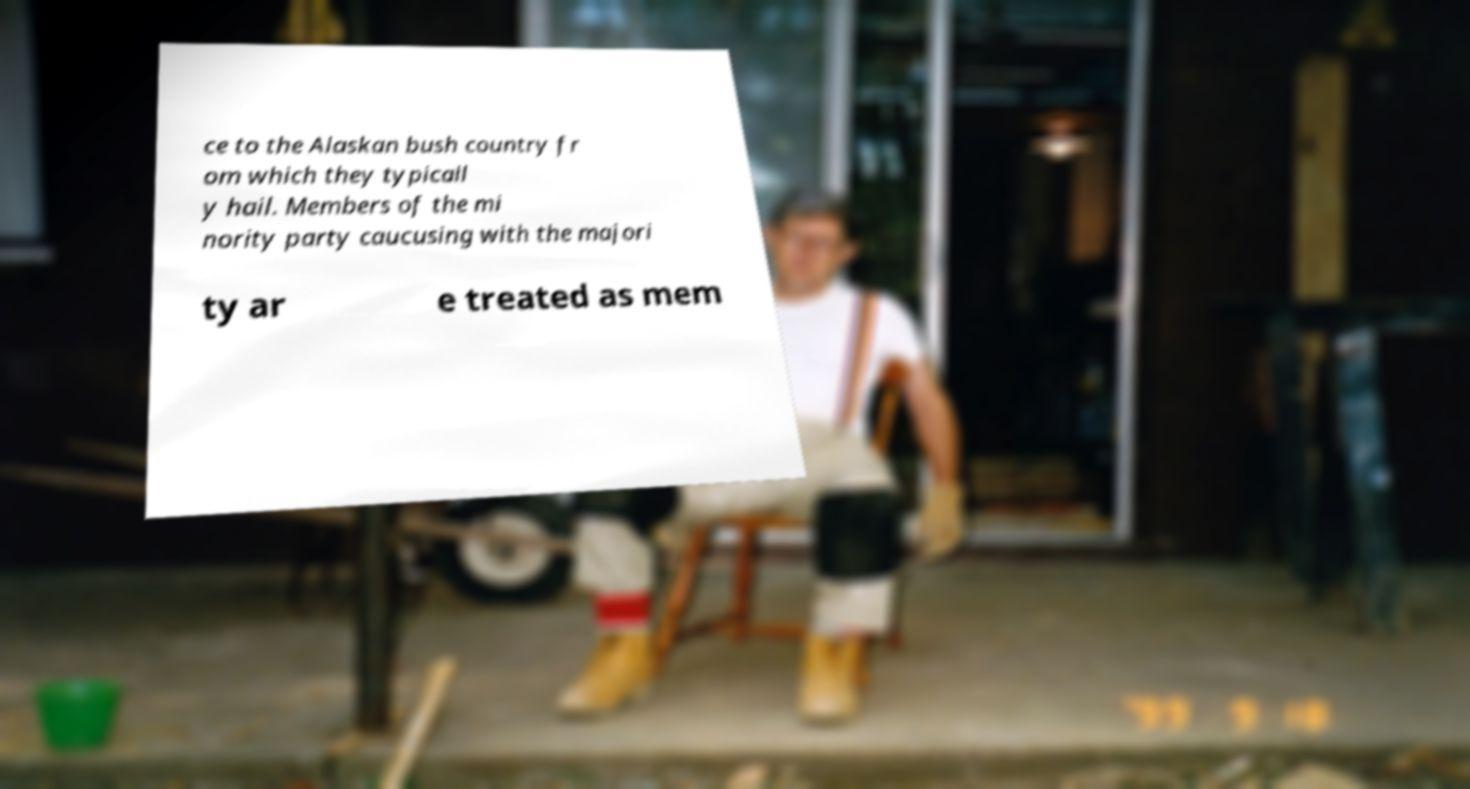I need the written content from this picture converted into text. Can you do that? ce to the Alaskan bush country fr om which they typicall y hail. Members of the mi nority party caucusing with the majori ty ar e treated as mem 